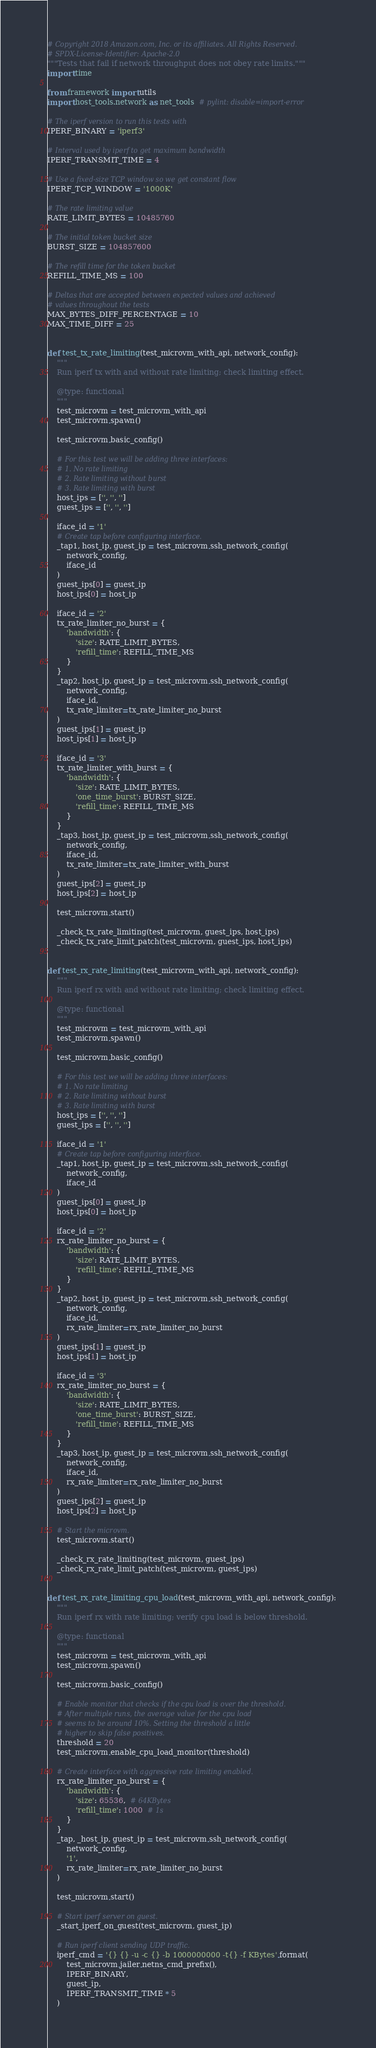<code> <loc_0><loc_0><loc_500><loc_500><_Python_># Copyright 2018 Amazon.com, Inc. or its affiliates. All Rights Reserved.
# SPDX-License-Identifier: Apache-2.0
"""Tests that fail if network throughput does not obey rate limits."""
import time

from framework import utils
import host_tools.network as net_tools  # pylint: disable=import-error

# The iperf version to run this tests with
IPERF_BINARY = 'iperf3'

# Interval used by iperf to get maximum bandwidth
IPERF_TRANSMIT_TIME = 4

# Use a fixed-size TCP window so we get constant flow
IPERF_TCP_WINDOW = '1000K'

# The rate limiting value
RATE_LIMIT_BYTES = 10485760

# The initial token bucket size
BURST_SIZE = 104857600

# The refill time for the token bucket
REFILL_TIME_MS = 100

# Deltas that are accepted between expected values and achieved
# values throughout the tests
MAX_BYTES_DIFF_PERCENTAGE = 10
MAX_TIME_DIFF = 25


def test_tx_rate_limiting(test_microvm_with_api, network_config):
    """
    Run iperf tx with and without rate limiting; check limiting effect.

    @type: functional
    """
    test_microvm = test_microvm_with_api
    test_microvm.spawn()

    test_microvm.basic_config()

    # For this test we will be adding three interfaces:
    # 1. No rate limiting
    # 2. Rate limiting without burst
    # 3. Rate limiting with burst
    host_ips = ['', '', '']
    guest_ips = ['', '', '']

    iface_id = '1'
    # Create tap before configuring interface.
    _tap1, host_ip, guest_ip = test_microvm.ssh_network_config(
        network_config,
        iface_id
    )
    guest_ips[0] = guest_ip
    host_ips[0] = host_ip

    iface_id = '2'
    tx_rate_limiter_no_burst = {
        'bandwidth': {
            'size': RATE_LIMIT_BYTES,
            'refill_time': REFILL_TIME_MS
        }
    }
    _tap2, host_ip, guest_ip = test_microvm.ssh_network_config(
        network_config,
        iface_id,
        tx_rate_limiter=tx_rate_limiter_no_burst
    )
    guest_ips[1] = guest_ip
    host_ips[1] = host_ip

    iface_id = '3'
    tx_rate_limiter_with_burst = {
        'bandwidth': {
            'size': RATE_LIMIT_BYTES,
            'one_time_burst': BURST_SIZE,
            'refill_time': REFILL_TIME_MS
        }
    }
    _tap3, host_ip, guest_ip = test_microvm.ssh_network_config(
        network_config,
        iface_id,
        tx_rate_limiter=tx_rate_limiter_with_burst
    )
    guest_ips[2] = guest_ip
    host_ips[2] = host_ip

    test_microvm.start()

    _check_tx_rate_limiting(test_microvm, guest_ips, host_ips)
    _check_tx_rate_limit_patch(test_microvm, guest_ips, host_ips)


def test_rx_rate_limiting(test_microvm_with_api, network_config):
    """
    Run iperf rx with and without rate limiting; check limiting effect.

    @type: functional
    """
    test_microvm = test_microvm_with_api
    test_microvm.spawn()

    test_microvm.basic_config()

    # For this test we will be adding three interfaces:
    # 1. No rate limiting
    # 2. Rate limiting without burst
    # 3. Rate limiting with burst
    host_ips = ['', '', '']
    guest_ips = ['', '', '']

    iface_id = '1'
    # Create tap before configuring interface.
    _tap1, host_ip, guest_ip = test_microvm.ssh_network_config(
        network_config,
        iface_id
    )
    guest_ips[0] = guest_ip
    host_ips[0] = host_ip

    iface_id = '2'
    rx_rate_limiter_no_burst = {
        'bandwidth': {
            'size': RATE_LIMIT_BYTES,
            'refill_time': REFILL_TIME_MS
        }
    }
    _tap2, host_ip, guest_ip = test_microvm.ssh_network_config(
        network_config,
        iface_id,
        rx_rate_limiter=rx_rate_limiter_no_burst
    )
    guest_ips[1] = guest_ip
    host_ips[1] = host_ip

    iface_id = '3'
    rx_rate_limiter_no_burst = {
        'bandwidth': {
            'size': RATE_LIMIT_BYTES,
            'one_time_burst': BURST_SIZE,
            'refill_time': REFILL_TIME_MS
        }
    }
    _tap3, host_ip, guest_ip = test_microvm.ssh_network_config(
        network_config,
        iface_id,
        rx_rate_limiter=rx_rate_limiter_no_burst
    )
    guest_ips[2] = guest_ip
    host_ips[2] = host_ip

    # Start the microvm.
    test_microvm.start()

    _check_rx_rate_limiting(test_microvm, guest_ips)
    _check_rx_rate_limit_patch(test_microvm, guest_ips)


def test_rx_rate_limiting_cpu_load(test_microvm_with_api, network_config):
    """
    Run iperf rx with rate limiting; verify cpu load is below threshold.

    @type: functional
    """
    test_microvm = test_microvm_with_api
    test_microvm.spawn()

    test_microvm.basic_config()

    # Enable monitor that checks if the cpu load is over the threshold.
    # After multiple runs, the average value for the cpu load
    # seems to be around 10%. Setting the threshold a little
    # higher to skip false positives.
    threshold = 20
    test_microvm.enable_cpu_load_monitor(threshold)

    # Create interface with aggressive rate limiting enabled.
    rx_rate_limiter_no_burst = {
        'bandwidth': {
            'size': 65536,  # 64KBytes
            'refill_time': 1000  # 1s
        }
    }
    _tap, _host_ip, guest_ip = test_microvm.ssh_network_config(
        network_config,
        '1',
        rx_rate_limiter=rx_rate_limiter_no_burst
    )

    test_microvm.start()

    # Start iperf server on guest.
    _start_iperf_on_guest(test_microvm, guest_ip)

    # Run iperf client sending UDP traffic.
    iperf_cmd = '{} {} -u -c {} -b 1000000000 -t{} -f KBytes'.format(
        test_microvm.jailer.netns_cmd_prefix(),
        IPERF_BINARY,
        guest_ip,
        IPERF_TRANSMIT_TIME * 5
    )</code> 